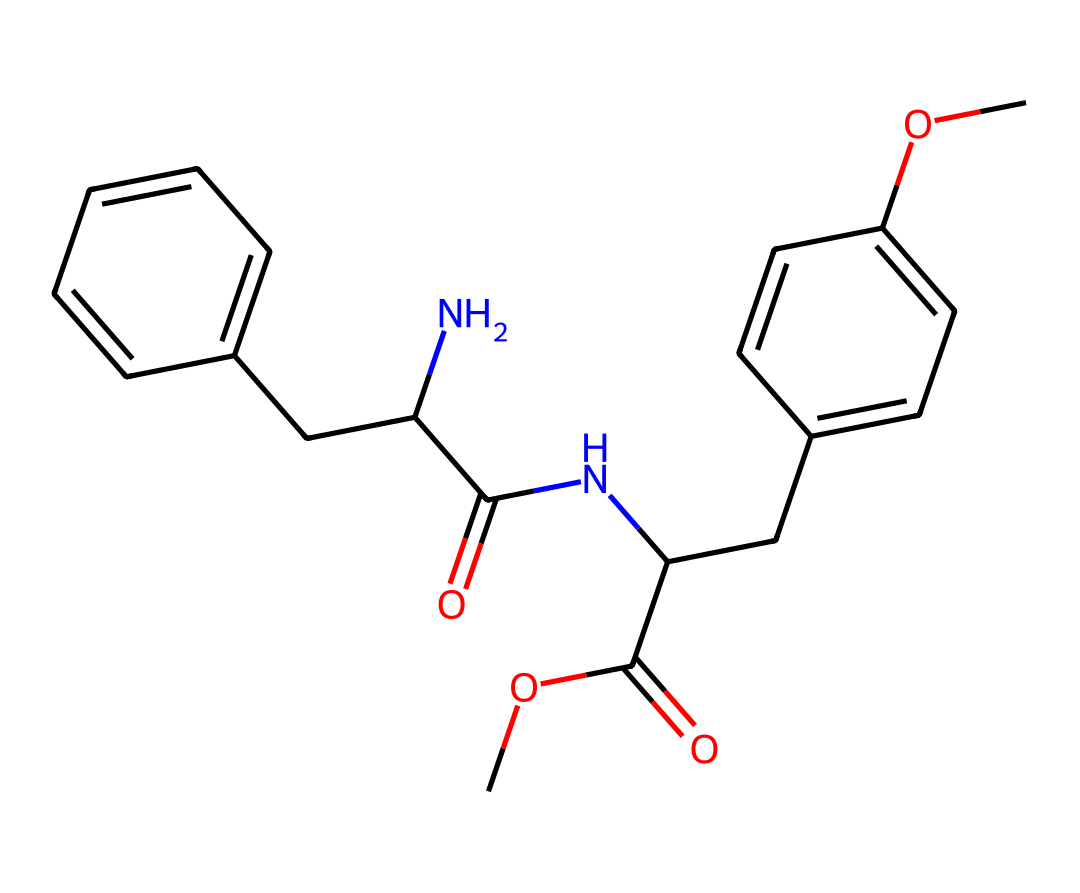What is the molecular formula of aspartame? To determine the molecular formula, count the types and quantities of each element in the SMILES representation. The counts are: Carbon (C): 14, Hydrogen (H): 18, Nitrogen (N): 2, and Oxygen (O): 5. Thus, the molecular formula is C14H18N2O5.
Answer: C14H18N2O5 How many nitrogen atoms are present in aspartame? By examining the SMILES representation, we can see that there are two 'N' symbols, which directly represent nitrogen atoms. Therefore, there are two nitrogen atoms in aspartame.
Answer: 2 What type of functional groups are present in aspartame? In the SMILES, we can identify an ester group (–COOC– from the methoxy and carbonyl) and two amide groups (–C(=O)N–) through the 'NC(=O)' segments. Therefore, we can conclude that both ester and amide groups are present.
Answer: ester and amide Which part of aspartame contributes to its sweetness? The sweet taste of aspartame comes from the presence of the phenylalanine portion. Specifically, the phenyl ring structure linked to other groups in the molecule is responsible for its sweet flavor.
Answer: phenylalanine How many rings are in the structure of aspartame? In the chemical structure, there are two aromatic rings as indicated by the two 'C' symbols with double-bonded 'C' connections and alternating single bonds inside them. This reveals two distinct ring structures in aspartame.
Answer: 2 What is the total number of carbon atoms in aspartame? By counting the carbon atoms represented by the 'C' symbols in the SMILES string, we find there are a total of 14 carbon atoms.
Answer: 14 